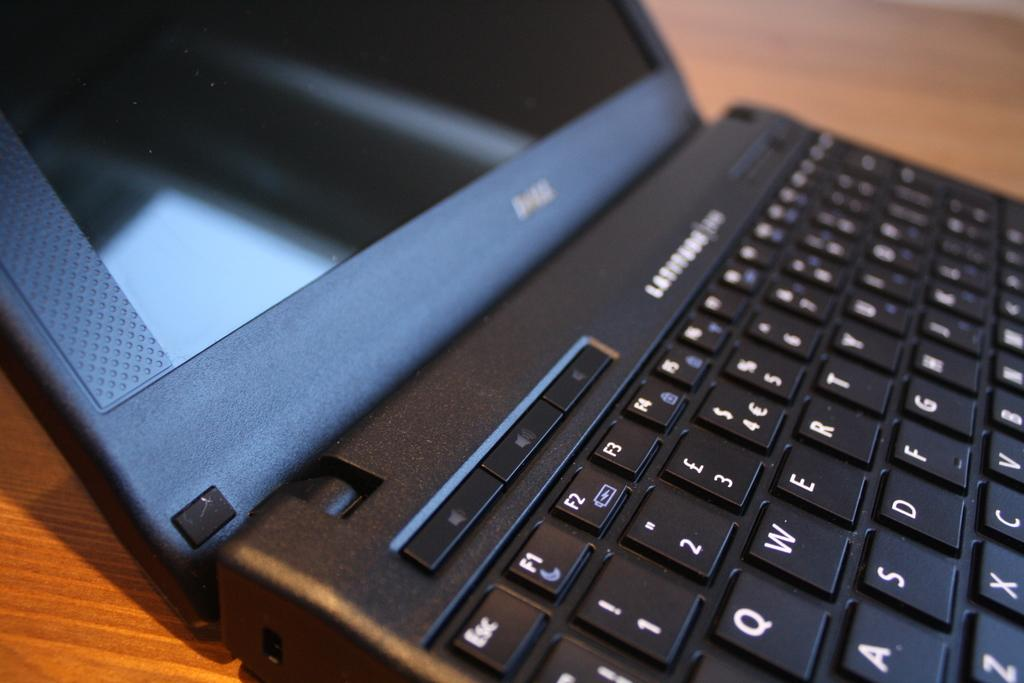What electronic device is visible in the image? There is a laptop in the image. What type of buttons can be seen on the laptop? There are key buttons in the image. What material is the surface that the laptop is placed on? There is a wooden surface in the image. What type of jeans is the laptop wearing in the image? There are no jeans present in the image, as the laptop is an inanimate object and does not wear clothing. 